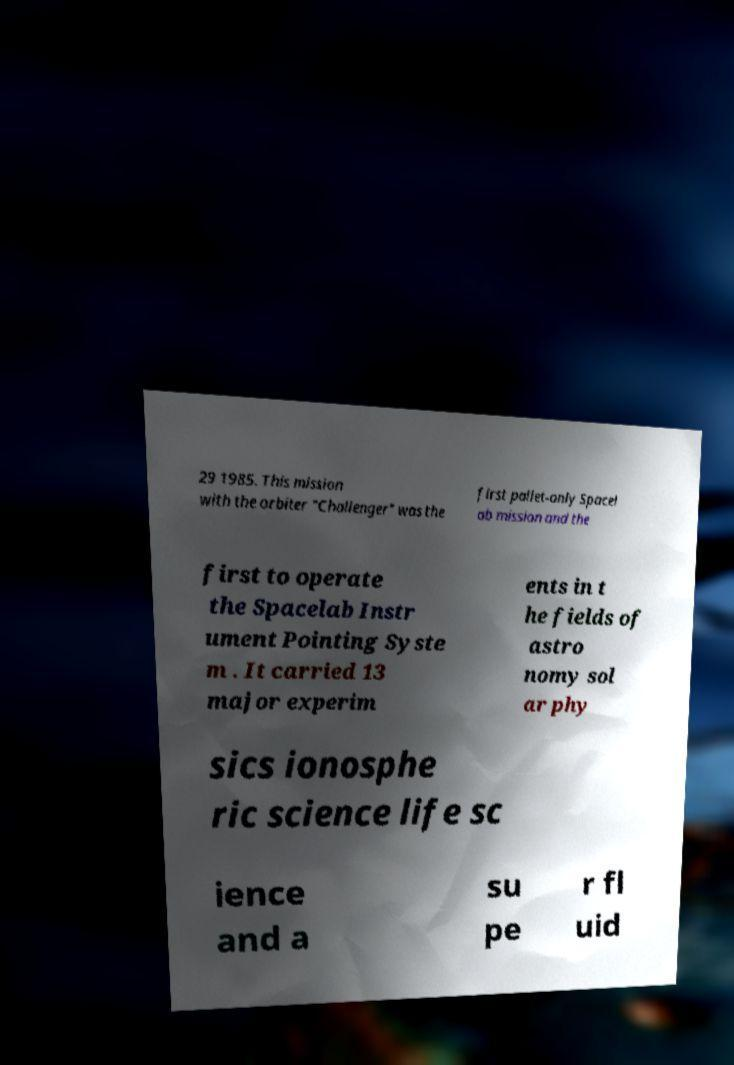For documentation purposes, I need the text within this image transcribed. Could you provide that? 29 1985. This mission with the orbiter "Challenger" was the first pallet-only Spacel ab mission and the first to operate the Spacelab Instr ument Pointing Syste m . It carried 13 major experim ents in t he fields of astro nomy sol ar phy sics ionosphe ric science life sc ience and a su pe r fl uid 